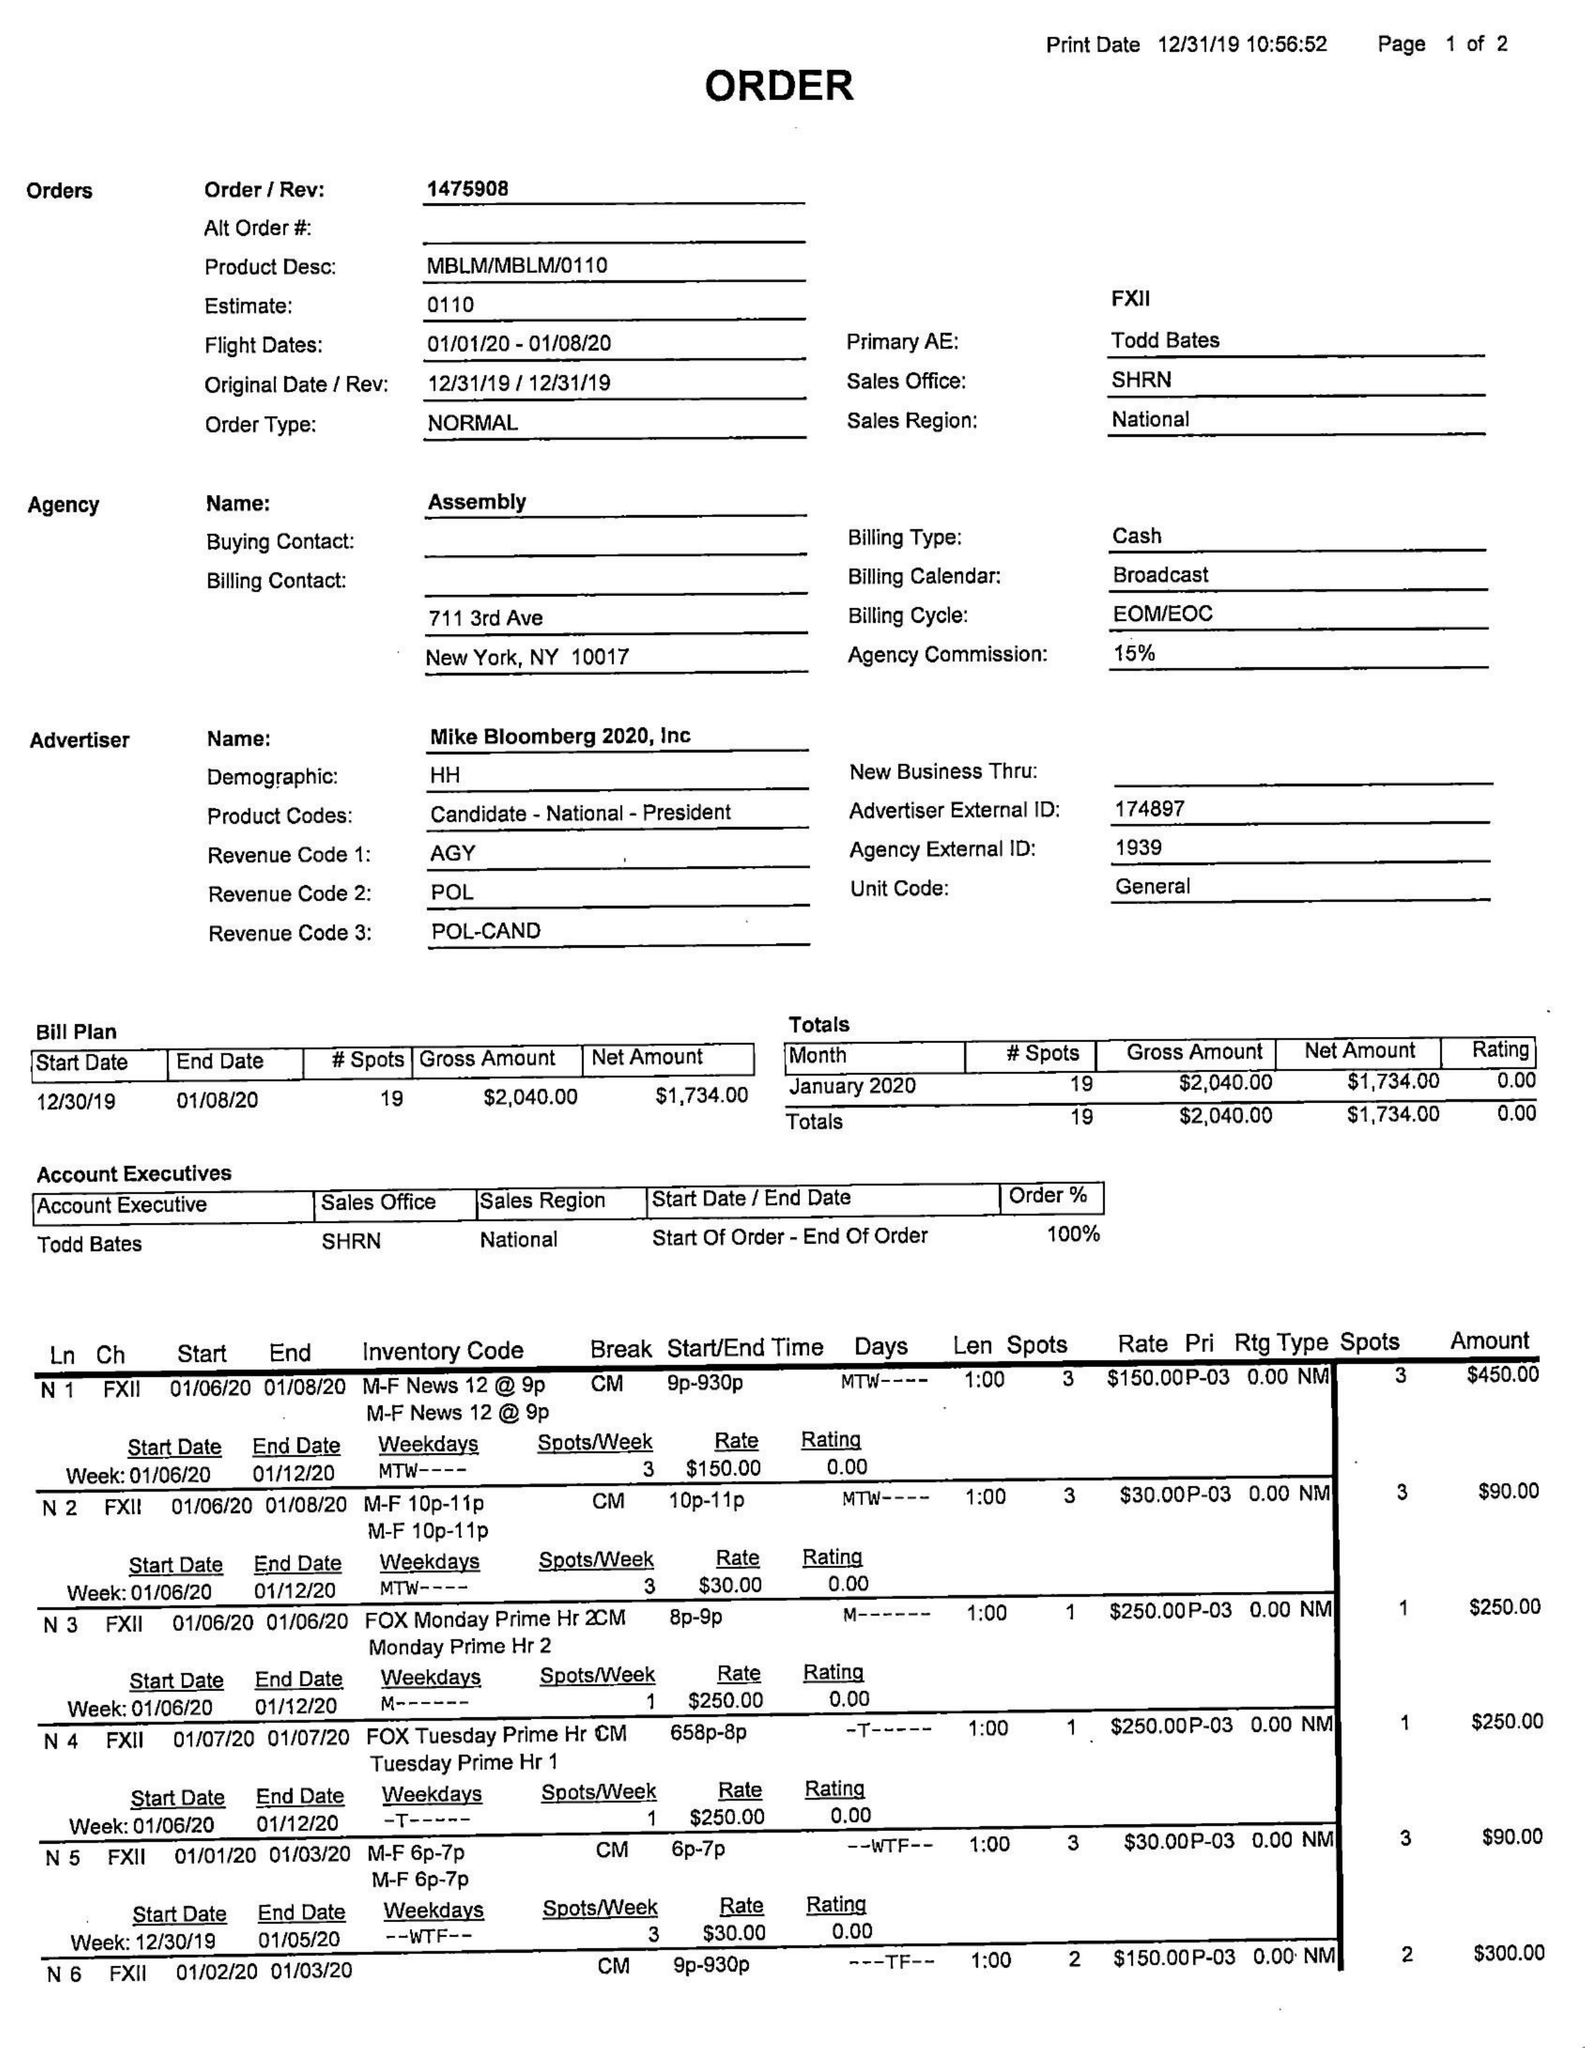What is the value for the flight_to?
Answer the question using a single word or phrase. 01/08/20 